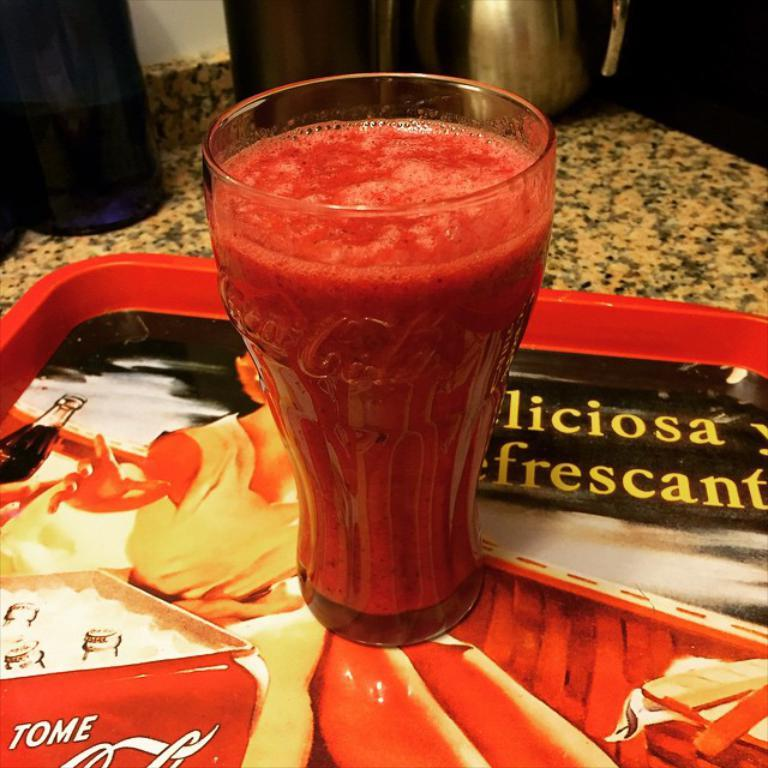What is in the glass that is visible in the image? There is a drink in the glass in the image. Where is the glass located in the image? The glass is on a tray in the image. What can be seen in the background of the image? There is a jug and other items on the table in the background. What type of lead is being used to add cakes to the image? There is no lead or cakes present in the image; it only features a glass with a drink on a tray and a jug in the background. 